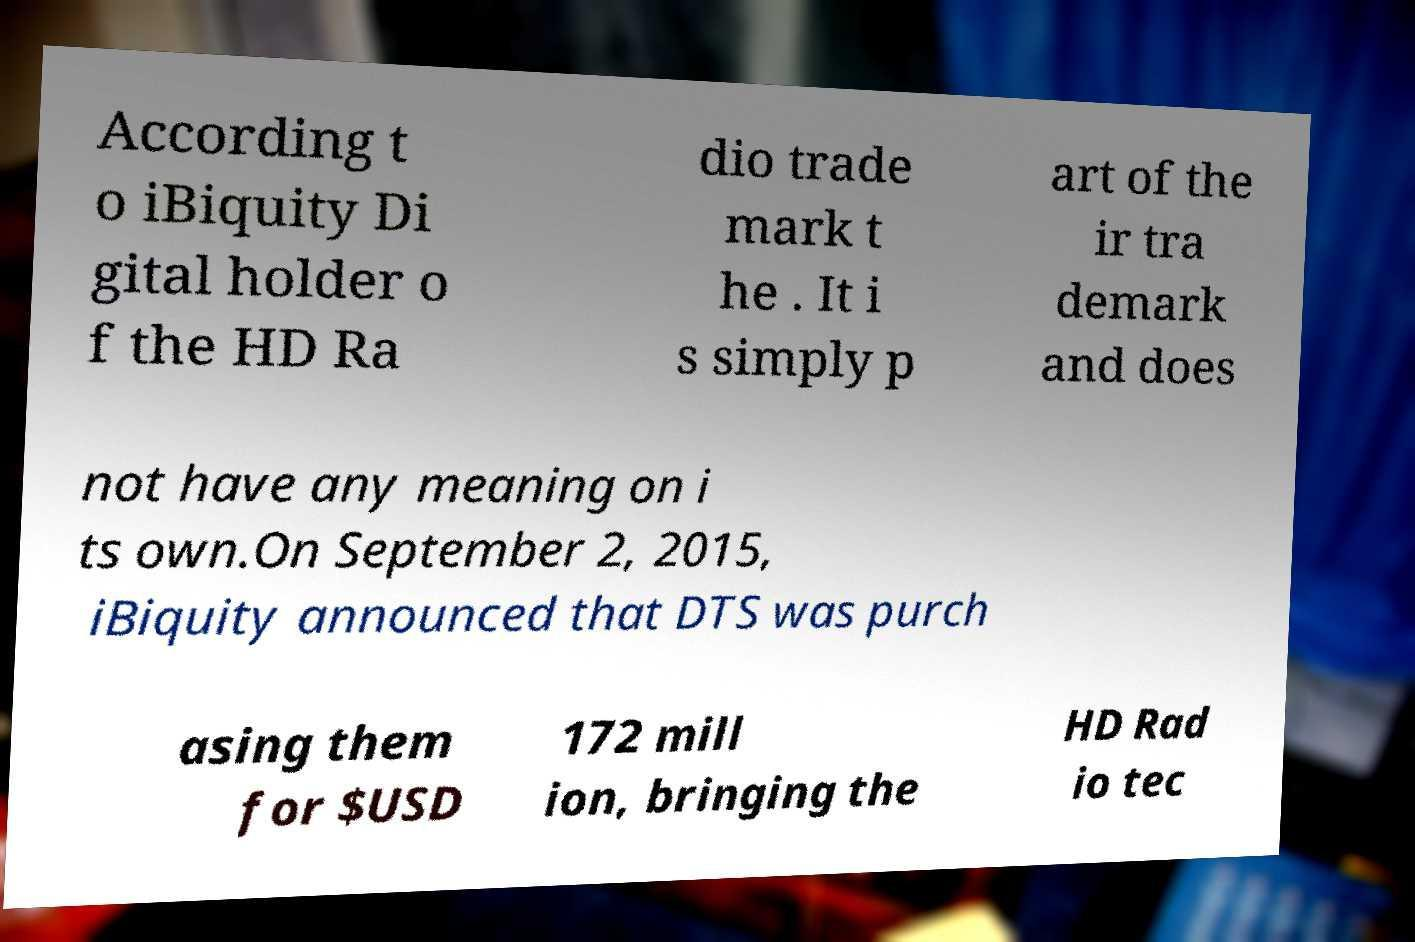Could you assist in decoding the text presented in this image and type it out clearly? According t o iBiquity Di gital holder o f the HD Ra dio trade mark t he . It i s simply p art of the ir tra demark and does not have any meaning on i ts own.On September 2, 2015, iBiquity announced that DTS was purch asing them for $USD 172 mill ion, bringing the HD Rad io tec 